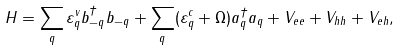Convert formula to latex. <formula><loc_0><loc_0><loc_500><loc_500>H = \sum _ { q } \varepsilon _ { q } ^ { v } b _ { - { q } } ^ { \dag } b _ { - { q } } + \sum _ { q } ( \varepsilon _ { q } ^ { c } + \Omega ) a ^ { \dag } _ { q } a _ { q } + V _ { e e } + V _ { h h } + V _ { e h } ,</formula> 